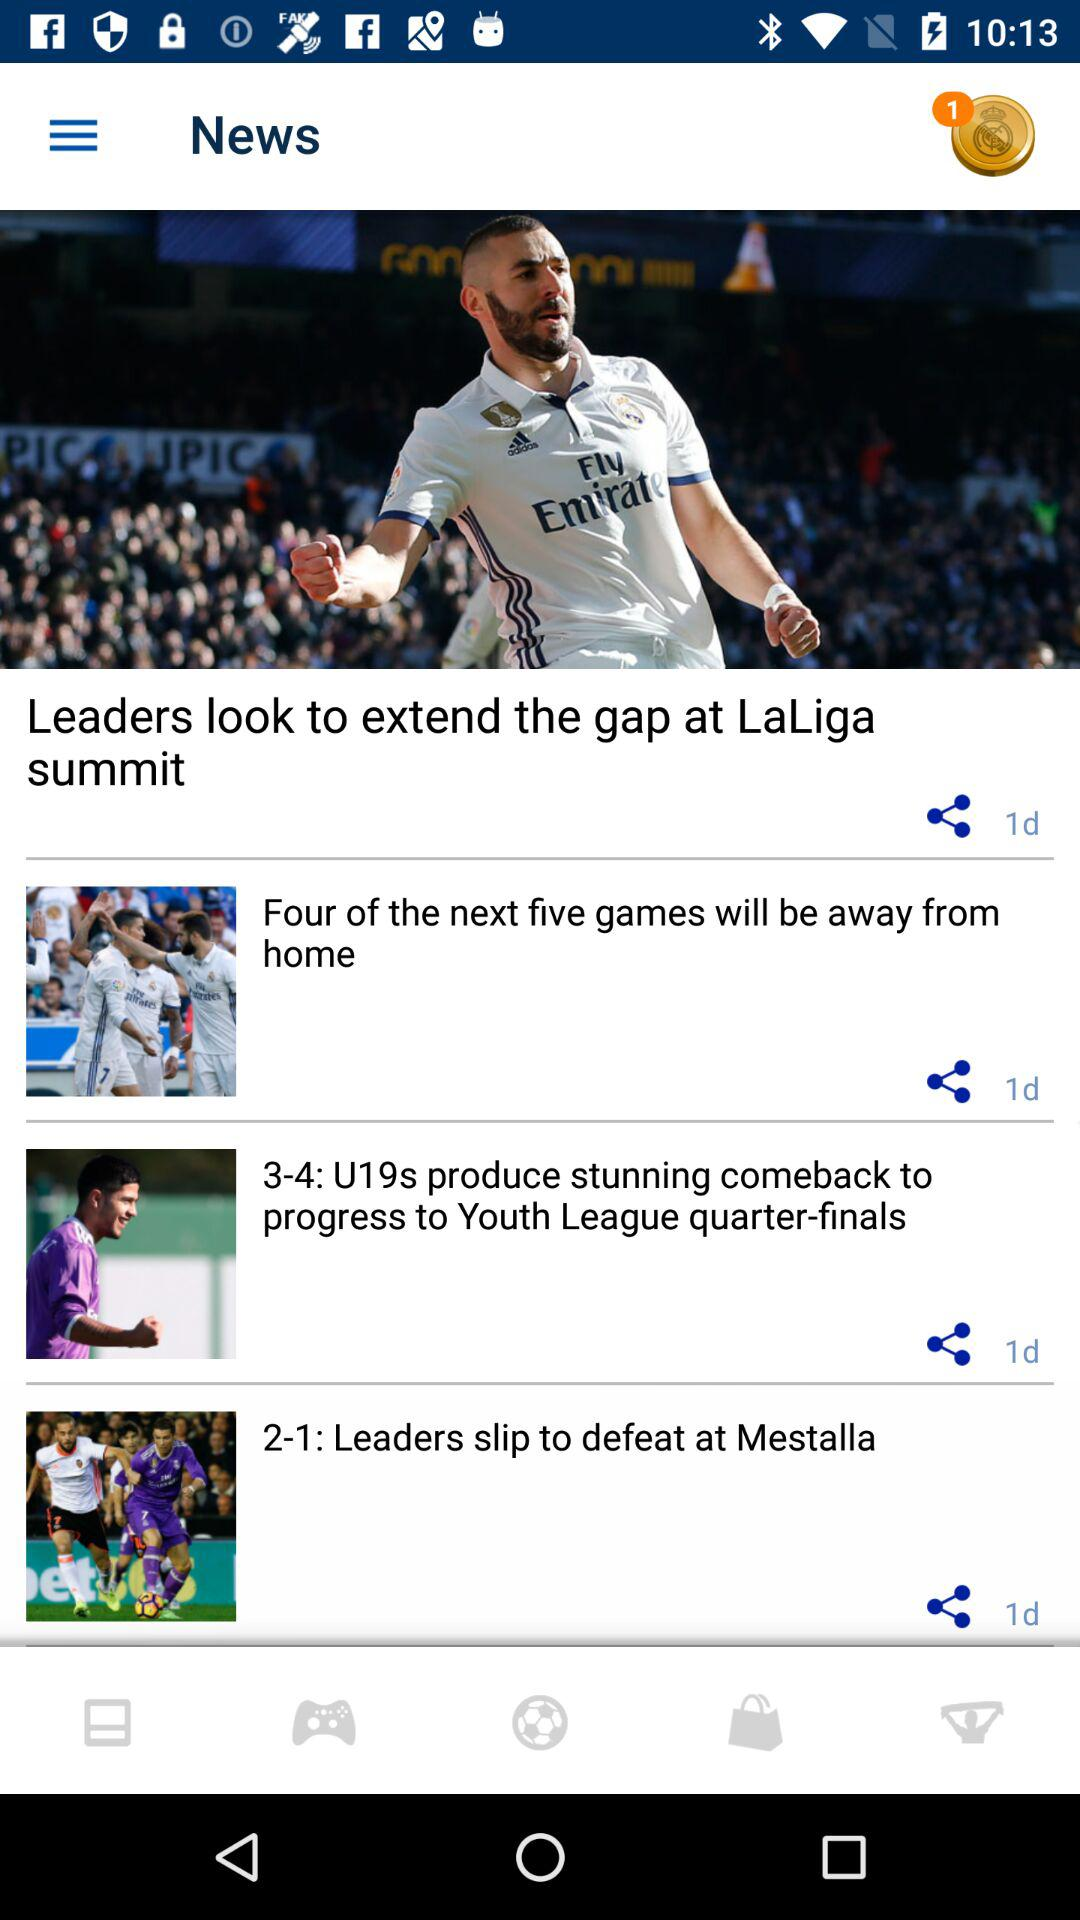What is the time duration of the publication of the youth league quarter finals? It was published 1 day ago. 